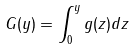<formula> <loc_0><loc_0><loc_500><loc_500>G ( y ) = \int _ { 0 } ^ { y } g ( z ) d z</formula> 